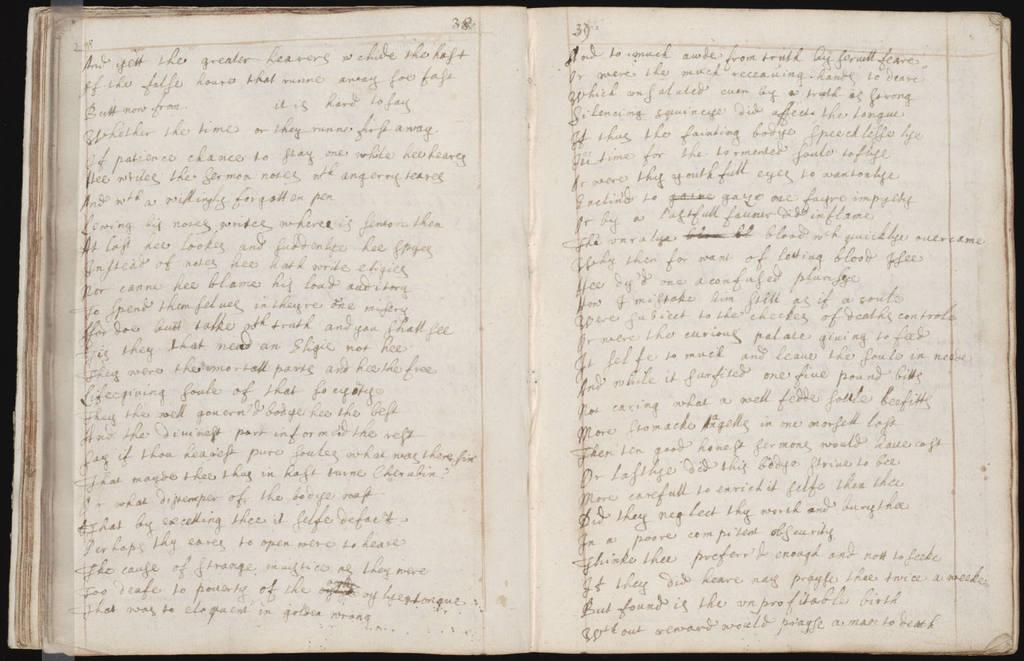<image>
Render a clear and concise summary of the photo. A handwritten journal is open to pages 38 and 39 